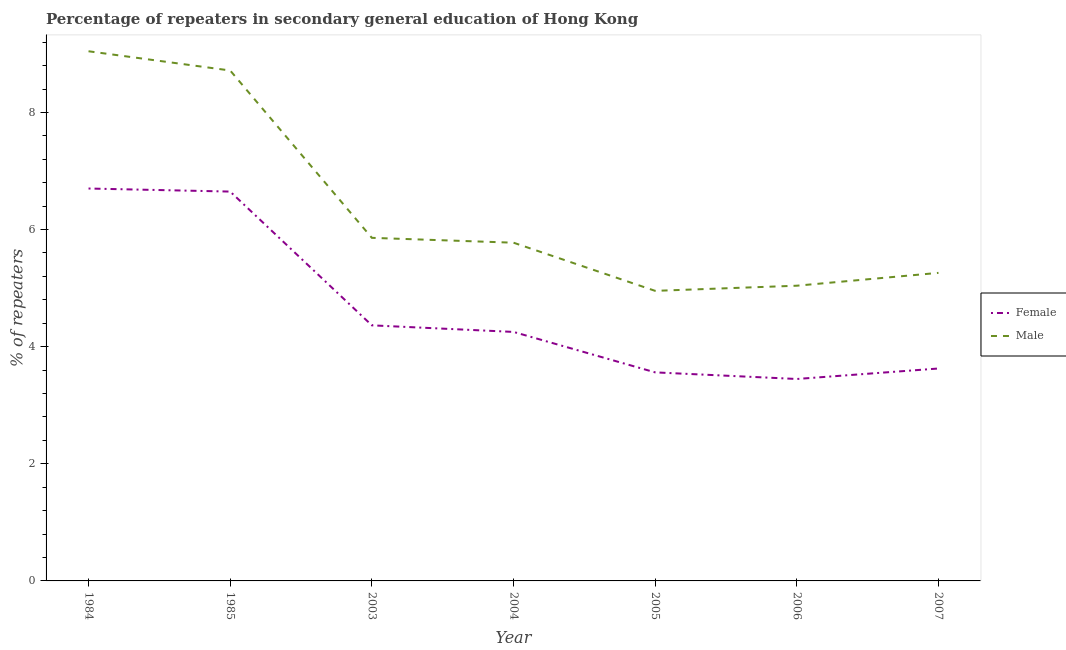How many different coloured lines are there?
Offer a terse response. 2. Is the number of lines equal to the number of legend labels?
Offer a terse response. Yes. What is the percentage of male repeaters in 2004?
Make the answer very short. 5.78. Across all years, what is the maximum percentage of female repeaters?
Give a very brief answer. 6.7. Across all years, what is the minimum percentage of female repeaters?
Ensure brevity in your answer.  3.45. In which year was the percentage of male repeaters maximum?
Ensure brevity in your answer.  1984. In which year was the percentage of male repeaters minimum?
Keep it short and to the point. 2005. What is the total percentage of male repeaters in the graph?
Make the answer very short. 44.65. What is the difference between the percentage of female repeaters in 2003 and that in 2006?
Make the answer very short. 0.92. What is the difference between the percentage of female repeaters in 2007 and the percentage of male repeaters in 1985?
Ensure brevity in your answer.  -5.09. What is the average percentage of female repeaters per year?
Ensure brevity in your answer.  4.66. In the year 2003, what is the difference between the percentage of male repeaters and percentage of female repeaters?
Your answer should be very brief. 1.49. What is the ratio of the percentage of male repeaters in 2006 to that in 2007?
Your answer should be compact. 0.96. Is the difference between the percentage of male repeaters in 2004 and 2007 greater than the difference between the percentage of female repeaters in 2004 and 2007?
Your response must be concise. No. What is the difference between the highest and the second highest percentage of female repeaters?
Provide a succinct answer. 0.05. What is the difference between the highest and the lowest percentage of male repeaters?
Keep it short and to the point. 4.09. In how many years, is the percentage of male repeaters greater than the average percentage of male repeaters taken over all years?
Keep it short and to the point. 2. Does the percentage of female repeaters monotonically increase over the years?
Provide a succinct answer. No. What is the difference between two consecutive major ticks on the Y-axis?
Ensure brevity in your answer.  2. Does the graph contain any zero values?
Provide a succinct answer. No. How many legend labels are there?
Your answer should be very brief. 2. How are the legend labels stacked?
Give a very brief answer. Vertical. What is the title of the graph?
Keep it short and to the point. Percentage of repeaters in secondary general education of Hong Kong. What is the label or title of the X-axis?
Provide a short and direct response. Year. What is the label or title of the Y-axis?
Your answer should be compact. % of repeaters. What is the % of repeaters in Female in 1984?
Your answer should be very brief. 6.7. What is the % of repeaters of Male in 1984?
Your answer should be very brief. 9.04. What is the % of repeaters in Female in 1985?
Ensure brevity in your answer.  6.65. What is the % of repeaters of Male in 1985?
Give a very brief answer. 8.72. What is the % of repeaters in Female in 2003?
Your answer should be very brief. 4.36. What is the % of repeaters of Male in 2003?
Offer a very short reply. 5.86. What is the % of repeaters in Female in 2004?
Make the answer very short. 4.25. What is the % of repeaters of Male in 2004?
Offer a very short reply. 5.78. What is the % of repeaters of Female in 2005?
Your response must be concise. 3.56. What is the % of repeaters of Male in 2005?
Your answer should be very brief. 4.95. What is the % of repeaters of Female in 2006?
Make the answer very short. 3.45. What is the % of repeaters of Male in 2006?
Provide a succinct answer. 5.04. What is the % of repeaters in Female in 2007?
Your answer should be very brief. 3.63. What is the % of repeaters of Male in 2007?
Your response must be concise. 5.26. Across all years, what is the maximum % of repeaters in Female?
Your answer should be compact. 6.7. Across all years, what is the maximum % of repeaters of Male?
Make the answer very short. 9.04. Across all years, what is the minimum % of repeaters in Female?
Your answer should be compact. 3.45. Across all years, what is the minimum % of repeaters of Male?
Offer a very short reply. 4.95. What is the total % of repeaters of Female in the graph?
Keep it short and to the point. 32.6. What is the total % of repeaters of Male in the graph?
Offer a very short reply. 44.65. What is the difference between the % of repeaters in Female in 1984 and that in 1985?
Offer a terse response. 0.05. What is the difference between the % of repeaters in Male in 1984 and that in 1985?
Your answer should be very brief. 0.33. What is the difference between the % of repeaters of Female in 1984 and that in 2003?
Give a very brief answer. 2.34. What is the difference between the % of repeaters of Male in 1984 and that in 2003?
Offer a very short reply. 3.19. What is the difference between the % of repeaters of Female in 1984 and that in 2004?
Ensure brevity in your answer.  2.45. What is the difference between the % of repeaters of Male in 1984 and that in 2004?
Keep it short and to the point. 3.27. What is the difference between the % of repeaters in Female in 1984 and that in 2005?
Your answer should be very brief. 3.14. What is the difference between the % of repeaters of Male in 1984 and that in 2005?
Make the answer very short. 4.09. What is the difference between the % of repeaters of Female in 1984 and that in 2006?
Give a very brief answer. 3.25. What is the difference between the % of repeaters of Male in 1984 and that in 2006?
Provide a succinct answer. 4. What is the difference between the % of repeaters in Female in 1984 and that in 2007?
Make the answer very short. 3.07. What is the difference between the % of repeaters of Male in 1984 and that in 2007?
Offer a terse response. 3.78. What is the difference between the % of repeaters in Female in 1985 and that in 2003?
Your answer should be very brief. 2.28. What is the difference between the % of repeaters in Male in 1985 and that in 2003?
Your answer should be compact. 2.86. What is the difference between the % of repeaters in Female in 1985 and that in 2004?
Give a very brief answer. 2.4. What is the difference between the % of repeaters of Male in 1985 and that in 2004?
Give a very brief answer. 2.94. What is the difference between the % of repeaters of Female in 1985 and that in 2005?
Offer a very short reply. 3.09. What is the difference between the % of repeaters in Male in 1985 and that in 2005?
Offer a very short reply. 3.76. What is the difference between the % of repeaters of Female in 1985 and that in 2006?
Keep it short and to the point. 3.2. What is the difference between the % of repeaters of Male in 1985 and that in 2006?
Offer a terse response. 3.67. What is the difference between the % of repeaters of Female in 1985 and that in 2007?
Your answer should be compact. 3.02. What is the difference between the % of repeaters in Male in 1985 and that in 2007?
Make the answer very short. 3.46. What is the difference between the % of repeaters in Female in 2003 and that in 2004?
Give a very brief answer. 0.11. What is the difference between the % of repeaters of Male in 2003 and that in 2004?
Provide a succinct answer. 0.08. What is the difference between the % of repeaters of Female in 2003 and that in 2005?
Ensure brevity in your answer.  0.8. What is the difference between the % of repeaters of Male in 2003 and that in 2005?
Offer a very short reply. 0.91. What is the difference between the % of repeaters of Female in 2003 and that in 2006?
Your response must be concise. 0.92. What is the difference between the % of repeaters in Male in 2003 and that in 2006?
Provide a short and direct response. 0.82. What is the difference between the % of repeaters of Female in 2003 and that in 2007?
Your answer should be compact. 0.74. What is the difference between the % of repeaters of Male in 2003 and that in 2007?
Provide a short and direct response. 0.6. What is the difference between the % of repeaters of Female in 2004 and that in 2005?
Keep it short and to the point. 0.69. What is the difference between the % of repeaters of Male in 2004 and that in 2005?
Provide a short and direct response. 0.82. What is the difference between the % of repeaters in Female in 2004 and that in 2006?
Give a very brief answer. 0.8. What is the difference between the % of repeaters of Male in 2004 and that in 2006?
Offer a terse response. 0.73. What is the difference between the % of repeaters in Female in 2004 and that in 2007?
Your answer should be very brief. 0.62. What is the difference between the % of repeaters in Male in 2004 and that in 2007?
Offer a very short reply. 0.52. What is the difference between the % of repeaters in Female in 2005 and that in 2006?
Ensure brevity in your answer.  0.11. What is the difference between the % of repeaters in Male in 2005 and that in 2006?
Keep it short and to the point. -0.09. What is the difference between the % of repeaters of Female in 2005 and that in 2007?
Your answer should be very brief. -0.07. What is the difference between the % of repeaters of Male in 2005 and that in 2007?
Ensure brevity in your answer.  -0.31. What is the difference between the % of repeaters of Female in 2006 and that in 2007?
Your answer should be compact. -0.18. What is the difference between the % of repeaters of Male in 2006 and that in 2007?
Offer a terse response. -0.22. What is the difference between the % of repeaters in Female in 1984 and the % of repeaters in Male in 1985?
Your response must be concise. -2.02. What is the difference between the % of repeaters of Female in 1984 and the % of repeaters of Male in 2003?
Your answer should be very brief. 0.84. What is the difference between the % of repeaters in Female in 1984 and the % of repeaters in Male in 2004?
Your answer should be very brief. 0.93. What is the difference between the % of repeaters of Female in 1984 and the % of repeaters of Male in 2005?
Offer a very short reply. 1.75. What is the difference between the % of repeaters in Female in 1984 and the % of repeaters in Male in 2006?
Make the answer very short. 1.66. What is the difference between the % of repeaters in Female in 1984 and the % of repeaters in Male in 2007?
Keep it short and to the point. 1.44. What is the difference between the % of repeaters in Female in 1985 and the % of repeaters in Male in 2003?
Make the answer very short. 0.79. What is the difference between the % of repeaters in Female in 1985 and the % of repeaters in Male in 2004?
Give a very brief answer. 0.87. What is the difference between the % of repeaters of Female in 1985 and the % of repeaters of Male in 2005?
Offer a terse response. 1.7. What is the difference between the % of repeaters in Female in 1985 and the % of repeaters in Male in 2006?
Give a very brief answer. 1.61. What is the difference between the % of repeaters in Female in 1985 and the % of repeaters in Male in 2007?
Keep it short and to the point. 1.39. What is the difference between the % of repeaters of Female in 2003 and the % of repeaters of Male in 2004?
Your answer should be compact. -1.41. What is the difference between the % of repeaters in Female in 2003 and the % of repeaters in Male in 2005?
Your response must be concise. -0.59. What is the difference between the % of repeaters in Female in 2003 and the % of repeaters in Male in 2006?
Provide a succinct answer. -0.68. What is the difference between the % of repeaters of Female in 2003 and the % of repeaters of Male in 2007?
Ensure brevity in your answer.  -0.9. What is the difference between the % of repeaters in Female in 2004 and the % of repeaters in Male in 2005?
Your answer should be very brief. -0.7. What is the difference between the % of repeaters in Female in 2004 and the % of repeaters in Male in 2006?
Your answer should be compact. -0.79. What is the difference between the % of repeaters in Female in 2004 and the % of repeaters in Male in 2007?
Your response must be concise. -1.01. What is the difference between the % of repeaters of Female in 2005 and the % of repeaters of Male in 2006?
Ensure brevity in your answer.  -1.48. What is the difference between the % of repeaters of Female in 2005 and the % of repeaters of Male in 2007?
Your answer should be very brief. -1.7. What is the difference between the % of repeaters in Female in 2006 and the % of repeaters in Male in 2007?
Offer a very short reply. -1.81. What is the average % of repeaters in Female per year?
Offer a very short reply. 4.66. What is the average % of repeaters in Male per year?
Keep it short and to the point. 6.38. In the year 1984, what is the difference between the % of repeaters of Female and % of repeaters of Male?
Make the answer very short. -2.34. In the year 1985, what is the difference between the % of repeaters in Female and % of repeaters in Male?
Provide a succinct answer. -2.07. In the year 2003, what is the difference between the % of repeaters of Female and % of repeaters of Male?
Make the answer very short. -1.49. In the year 2004, what is the difference between the % of repeaters of Female and % of repeaters of Male?
Make the answer very short. -1.52. In the year 2005, what is the difference between the % of repeaters of Female and % of repeaters of Male?
Keep it short and to the point. -1.39. In the year 2006, what is the difference between the % of repeaters of Female and % of repeaters of Male?
Provide a succinct answer. -1.59. In the year 2007, what is the difference between the % of repeaters in Female and % of repeaters in Male?
Provide a short and direct response. -1.63. What is the ratio of the % of repeaters of Female in 1984 to that in 1985?
Your answer should be compact. 1.01. What is the ratio of the % of repeaters in Male in 1984 to that in 1985?
Keep it short and to the point. 1.04. What is the ratio of the % of repeaters of Female in 1984 to that in 2003?
Provide a short and direct response. 1.54. What is the ratio of the % of repeaters of Male in 1984 to that in 2003?
Give a very brief answer. 1.54. What is the ratio of the % of repeaters in Female in 1984 to that in 2004?
Provide a succinct answer. 1.58. What is the ratio of the % of repeaters of Male in 1984 to that in 2004?
Make the answer very short. 1.57. What is the ratio of the % of repeaters in Female in 1984 to that in 2005?
Your response must be concise. 1.88. What is the ratio of the % of repeaters of Male in 1984 to that in 2005?
Provide a short and direct response. 1.83. What is the ratio of the % of repeaters of Female in 1984 to that in 2006?
Keep it short and to the point. 1.94. What is the ratio of the % of repeaters in Male in 1984 to that in 2006?
Offer a very short reply. 1.79. What is the ratio of the % of repeaters of Female in 1984 to that in 2007?
Offer a very short reply. 1.85. What is the ratio of the % of repeaters in Male in 1984 to that in 2007?
Give a very brief answer. 1.72. What is the ratio of the % of repeaters of Female in 1985 to that in 2003?
Keep it short and to the point. 1.52. What is the ratio of the % of repeaters of Male in 1985 to that in 2003?
Your answer should be compact. 1.49. What is the ratio of the % of repeaters of Female in 1985 to that in 2004?
Your answer should be very brief. 1.56. What is the ratio of the % of repeaters in Male in 1985 to that in 2004?
Provide a succinct answer. 1.51. What is the ratio of the % of repeaters of Female in 1985 to that in 2005?
Provide a succinct answer. 1.87. What is the ratio of the % of repeaters in Male in 1985 to that in 2005?
Provide a short and direct response. 1.76. What is the ratio of the % of repeaters in Female in 1985 to that in 2006?
Offer a very short reply. 1.93. What is the ratio of the % of repeaters of Male in 1985 to that in 2006?
Your answer should be compact. 1.73. What is the ratio of the % of repeaters in Female in 1985 to that in 2007?
Your answer should be very brief. 1.83. What is the ratio of the % of repeaters in Male in 1985 to that in 2007?
Offer a very short reply. 1.66. What is the ratio of the % of repeaters in Female in 2003 to that in 2004?
Give a very brief answer. 1.03. What is the ratio of the % of repeaters of Male in 2003 to that in 2004?
Give a very brief answer. 1.01. What is the ratio of the % of repeaters in Female in 2003 to that in 2005?
Offer a terse response. 1.23. What is the ratio of the % of repeaters of Male in 2003 to that in 2005?
Make the answer very short. 1.18. What is the ratio of the % of repeaters of Female in 2003 to that in 2006?
Give a very brief answer. 1.27. What is the ratio of the % of repeaters of Male in 2003 to that in 2006?
Make the answer very short. 1.16. What is the ratio of the % of repeaters in Female in 2003 to that in 2007?
Make the answer very short. 1.2. What is the ratio of the % of repeaters in Male in 2003 to that in 2007?
Give a very brief answer. 1.11. What is the ratio of the % of repeaters in Female in 2004 to that in 2005?
Your answer should be compact. 1.19. What is the ratio of the % of repeaters in Male in 2004 to that in 2005?
Give a very brief answer. 1.17. What is the ratio of the % of repeaters of Female in 2004 to that in 2006?
Your answer should be very brief. 1.23. What is the ratio of the % of repeaters in Male in 2004 to that in 2006?
Ensure brevity in your answer.  1.15. What is the ratio of the % of repeaters in Female in 2004 to that in 2007?
Make the answer very short. 1.17. What is the ratio of the % of repeaters in Male in 2004 to that in 2007?
Provide a short and direct response. 1.1. What is the ratio of the % of repeaters in Female in 2005 to that in 2006?
Your answer should be compact. 1.03. What is the ratio of the % of repeaters of Male in 2005 to that in 2006?
Your answer should be compact. 0.98. What is the ratio of the % of repeaters of Female in 2005 to that in 2007?
Your answer should be very brief. 0.98. What is the ratio of the % of repeaters of Male in 2005 to that in 2007?
Ensure brevity in your answer.  0.94. What is the ratio of the % of repeaters in Female in 2006 to that in 2007?
Provide a short and direct response. 0.95. What is the difference between the highest and the second highest % of repeaters of Female?
Ensure brevity in your answer.  0.05. What is the difference between the highest and the second highest % of repeaters in Male?
Ensure brevity in your answer.  0.33. What is the difference between the highest and the lowest % of repeaters of Female?
Provide a succinct answer. 3.25. What is the difference between the highest and the lowest % of repeaters of Male?
Your answer should be very brief. 4.09. 